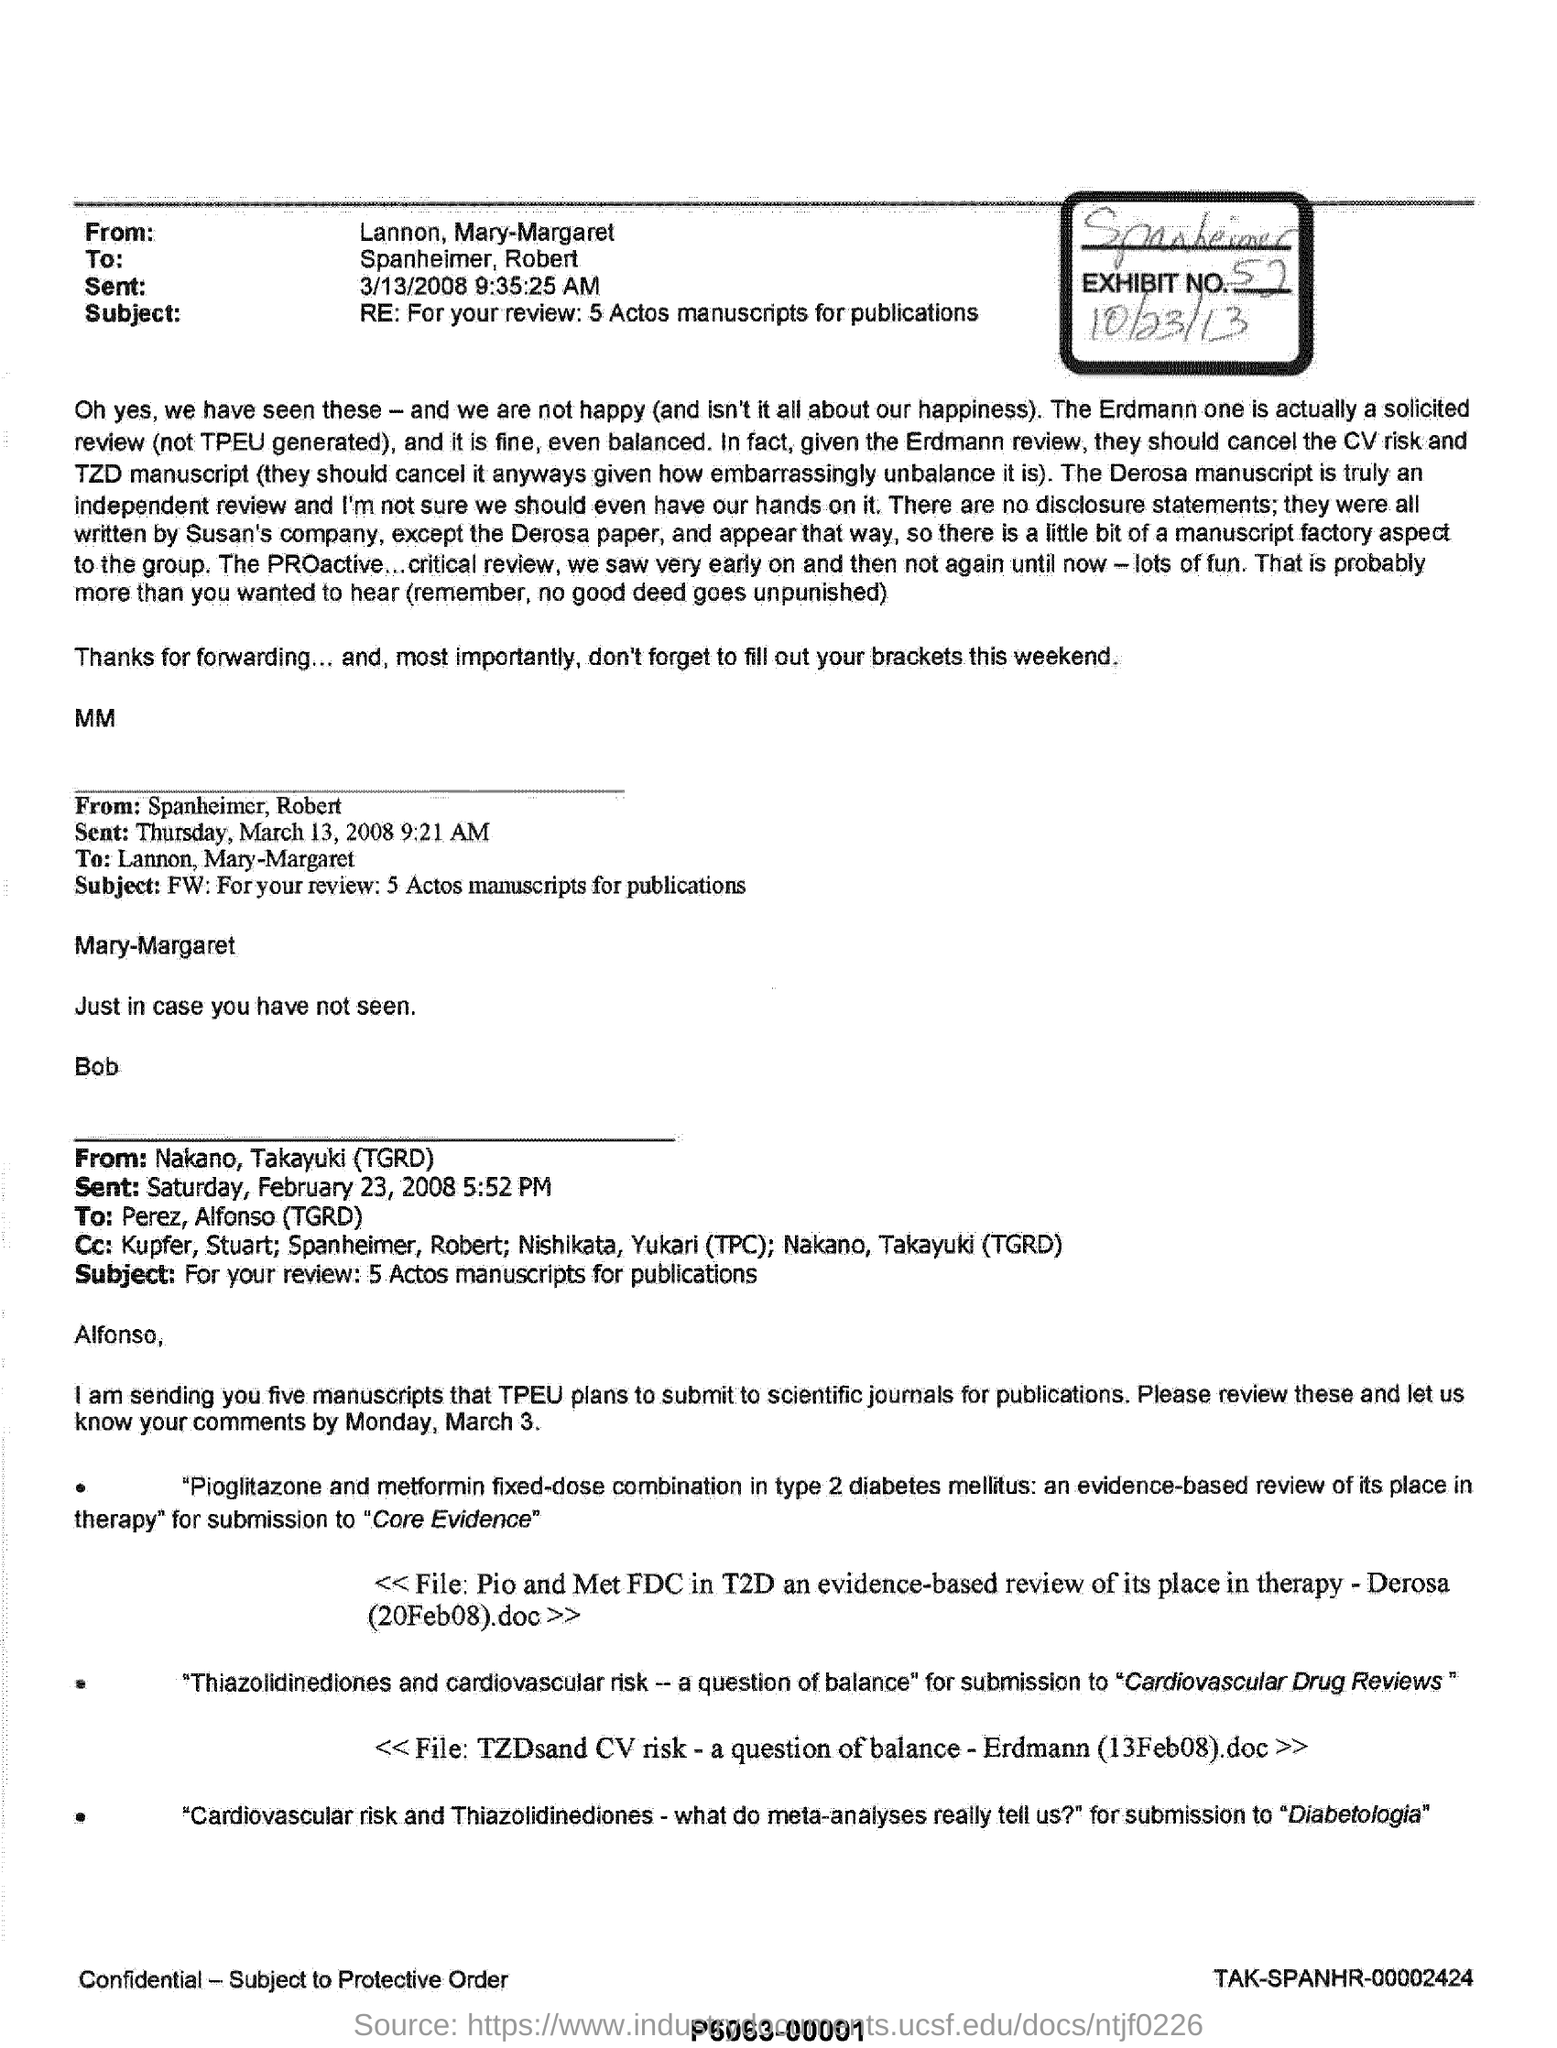What is the subject of the email from Lannon, Mary-Margaret?
Provide a succinct answer. RE: For your review: 5 Actos manuscripts for publications. What is the sent date and time of the email from Spanheimer, Robert?
Your response must be concise. Thursday, March 13, 2008 9:21 AM. What is the subject of the email form Nakano, Takayuki (TGRD)?
Offer a terse response. For your review: 5 Actos manuscripts for publications. What is the sent date and time of the email from Lannon, Mary-Margaret?
Offer a terse response. 3/13/2008 9:35:25 AM. 